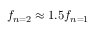Convert formula to latex. <formula><loc_0><loc_0><loc_500><loc_500>f _ { n = 2 } \approx 1 . 5 f _ { n = 1 }</formula> 